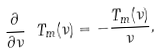<formula> <loc_0><loc_0><loc_500><loc_500>\frac { \partial } { \partial \nu } \ T _ { m } ( \nu ) = - \frac { T _ { m } ( \nu ) } { \nu } ,</formula> 